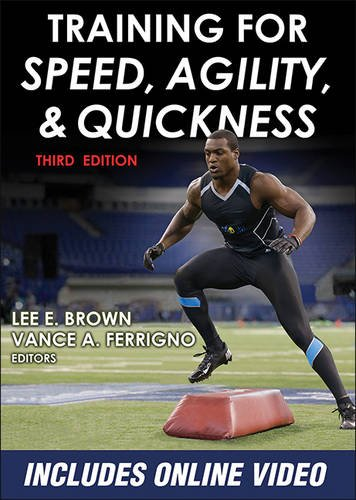What is the title of this book? The title of the book displayed in the image is 'Training for Speed, Agility, and Quickness - 3rd Edition.' This book is a comprehensive guide focusing on improving physical abilities relevant to multiple sports. 